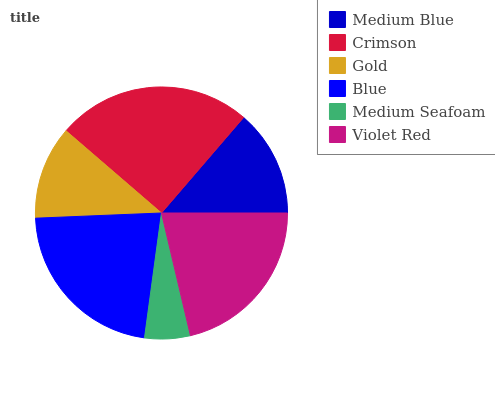Is Medium Seafoam the minimum?
Answer yes or no. Yes. Is Crimson the maximum?
Answer yes or no. Yes. Is Gold the minimum?
Answer yes or no. No. Is Gold the maximum?
Answer yes or no. No. Is Crimson greater than Gold?
Answer yes or no. Yes. Is Gold less than Crimson?
Answer yes or no. Yes. Is Gold greater than Crimson?
Answer yes or no. No. Is Crimson less than Gold?
Answer yes or no. No. Is Violet Red the high median?
Answer yes or no. Yes. Is Medium Blue the low median?
Answer yes or no. Yes. Is Medium Blue the high median?
Answer yes or no. No. Is Gold the low median?
Answer yes or no. No. 